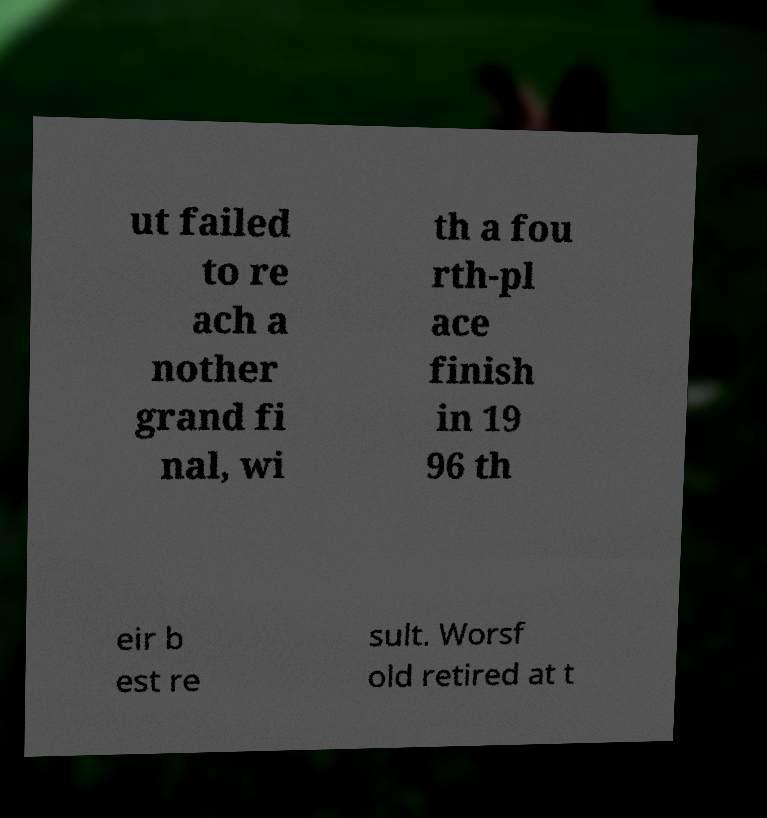There's text embedded in this image that I need extracted. Can you transcribe it verbatim? ut failed to re ach a nother grand fi nal, wi th a fou rth-pl ace finish in 19 96 th eir b est re sult. Worsf old retired at t 